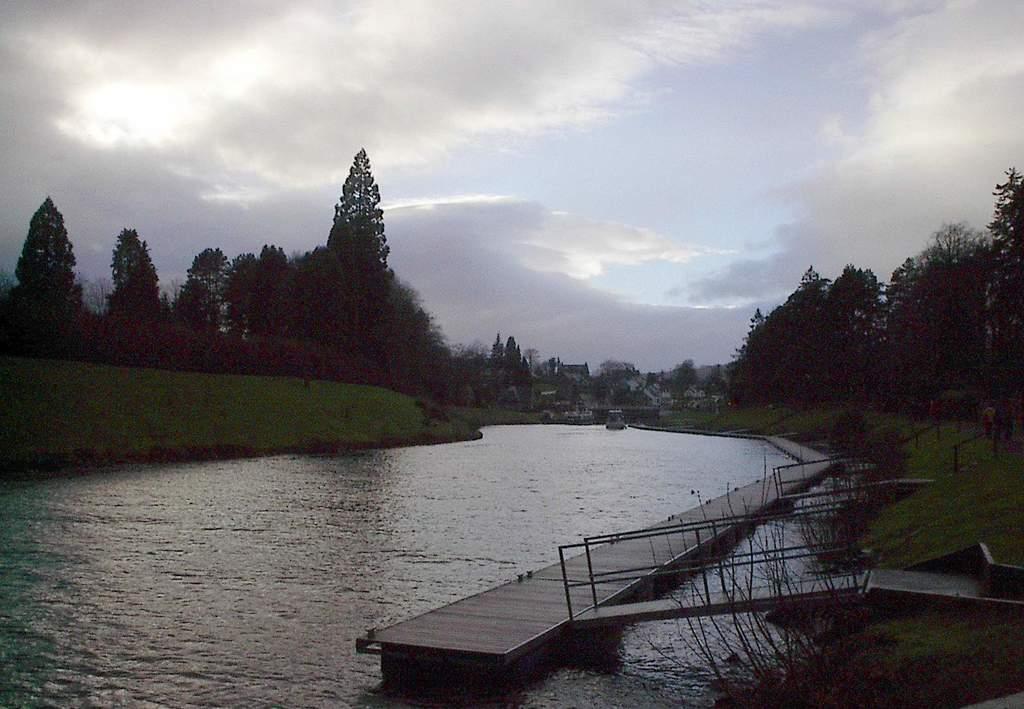Describe this image in one or two sentences. In the center of the image, we can see water and there is a bridge with stairs. In the background, there are trees and buildings and at the top, there are clouds in the sky. 